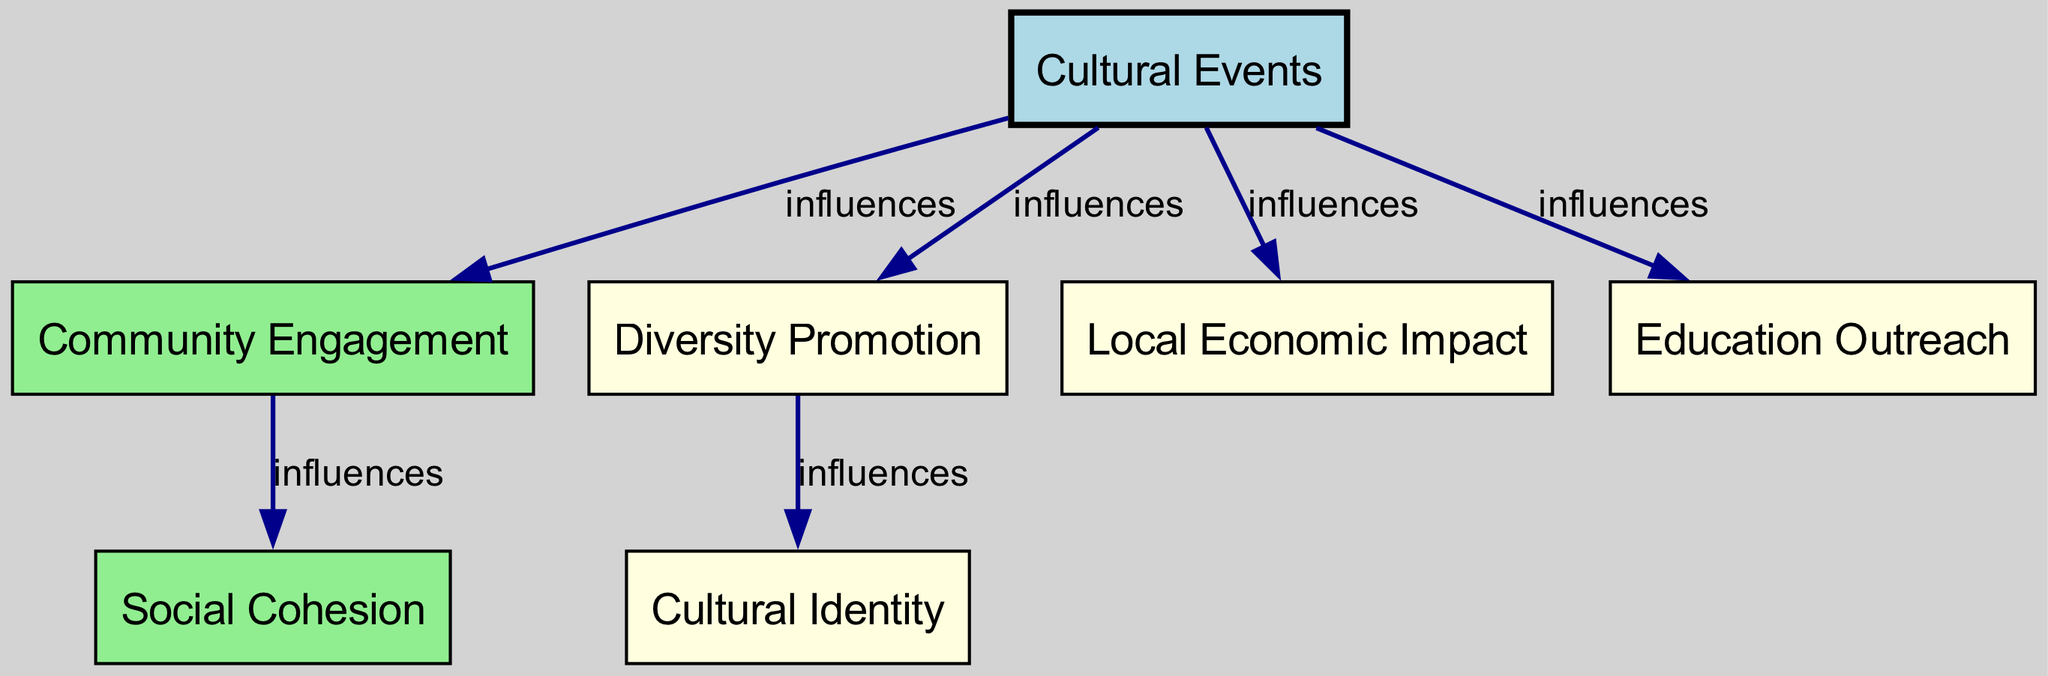What is the total number of nodes in the diagram? The diagram contains six unique nodes: Cultural Events, Community Engagement, Social Cohesion, Diversity Promotion, Local Economic Impact, and Education Outreach. Counting these gives a total of six nodes.
Answer: 6 Which node is influenced directly by Cultural Events and also influences Social Cohesion? The node Community Engagement is directly influenced by Cultural Events, and it further influences Social Cohesion. This means Community Engagement serves as a bridge between Cultural Events and Social Cohesion.
Answer: Community Engagement How many edges are connected to the Cultural Events node? Cultural Events has five direct influences, namely Community Engagement, Diversity Promotion, Local Economic Impact, and Education Outreach. Thus, there are four edges connected to Cultural Events.
Answer: 4 Which node promotes Cultural Identity? The node Diversity Promotion promotes Cultural Identity. This is indicated by the directed edge from Diversity Promotion to Cultural Identity, showing a direct influence.
Answer: Diversity Promotion If Cultural Events influence Community Engagement, what is the next impact along the flow? After Cultural Events influence Community Engagement, the flow continues to Social Cohesion. Therefore, the immediate next impact in the influence chain is Social Cohesion, established by the directed edge from Community Engagement to Social Cohesion.
Answer: Social Cohesion What type of relationship is represented by the edges in this directed graph? The edges in the directed graph represent an "influences" relationship, as indicated by the labeled edges connecting the nodes. Each edge shows that one node directly influences another.
Answer: influences Which node does not have any outgoing edges? The node Cultural Identity does not have any outgoing edges, indicating it does not influence any other node in this directed graph.
Answer: Cultural Identity How many types of impacts are shown stemming from Cultural Events? There are four types of impacts shown stemming directly from Cultural Events: Community Engagement, Diversity Promotion, Local Economic Impact, and Education Outreach. This indicates the various dimensions of influence that Cultural Events hold within the community.
Answer: 4 